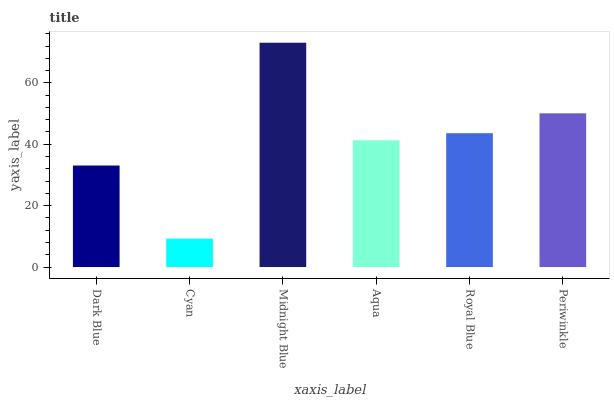Is Cyan the minimum?
Answer yes or no. Yes. Is Midnight Blue the maximum?
Answer yes or no. Yes. Is Midnight Blue the minimum?
Answer yes or no. No. Is Cyan the maximum?
Answer yes or no. No. Is Midnight Blue greater than Cyan?
Answer yes or no. Yes. Is Cyan less than Midnight Blue?
Answer yes or no. Yes. Is Cyan greater than Midnight Blue?
Answer yes or no. No. Is Midnight Blue less than Cyan?
Answer yes or no. No. Is Royal Blue the high median?
Answer yes or no. Yes. Is Aqua the low median?
Answer yes or no. Yes. Is Midnight Blue the high median?
Answer yes or no. No. Is Periwinkle the low median?
Answer yes or no. No. 